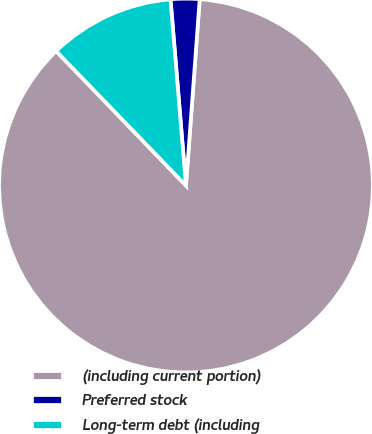Convert chart to OTSL. <chart><loc_0><loc_0><loc_500><loc_500><pie_chart><fcel>(including current portion)<fcel>Preferred stock<fcel>Long-term debt (including<nl><fcel>86.61%<fcel>2.49%<fcel>10.9%<nl></chart> 